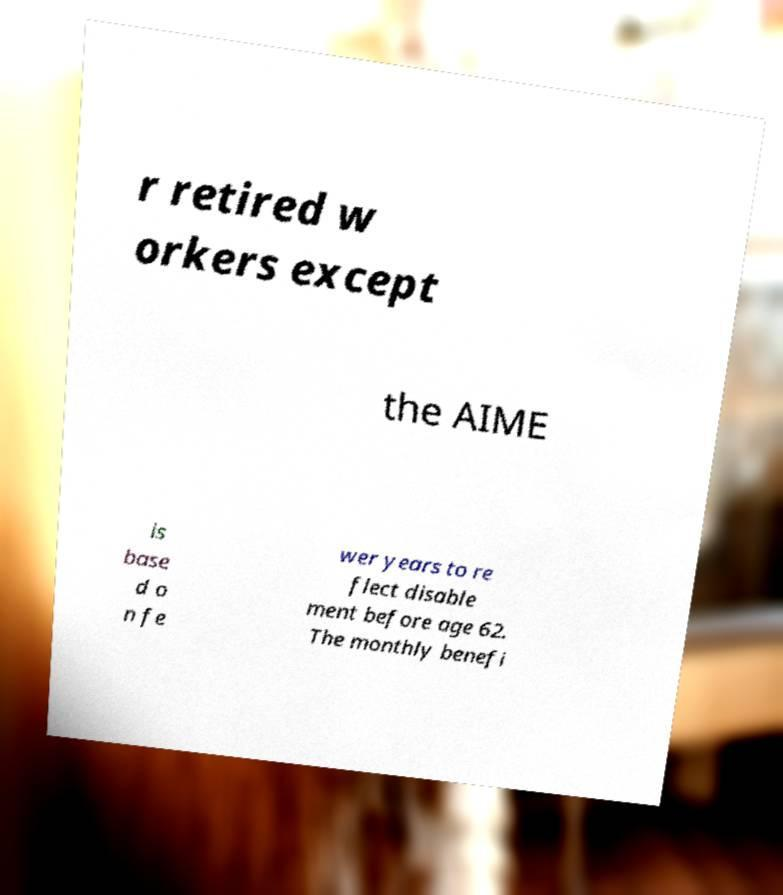Please read and relay the text visible in this image. What does it say? r retired w orkers except the AIME is base d o n fe wer years to re flect disable ment before age 62. The monthly benefi 